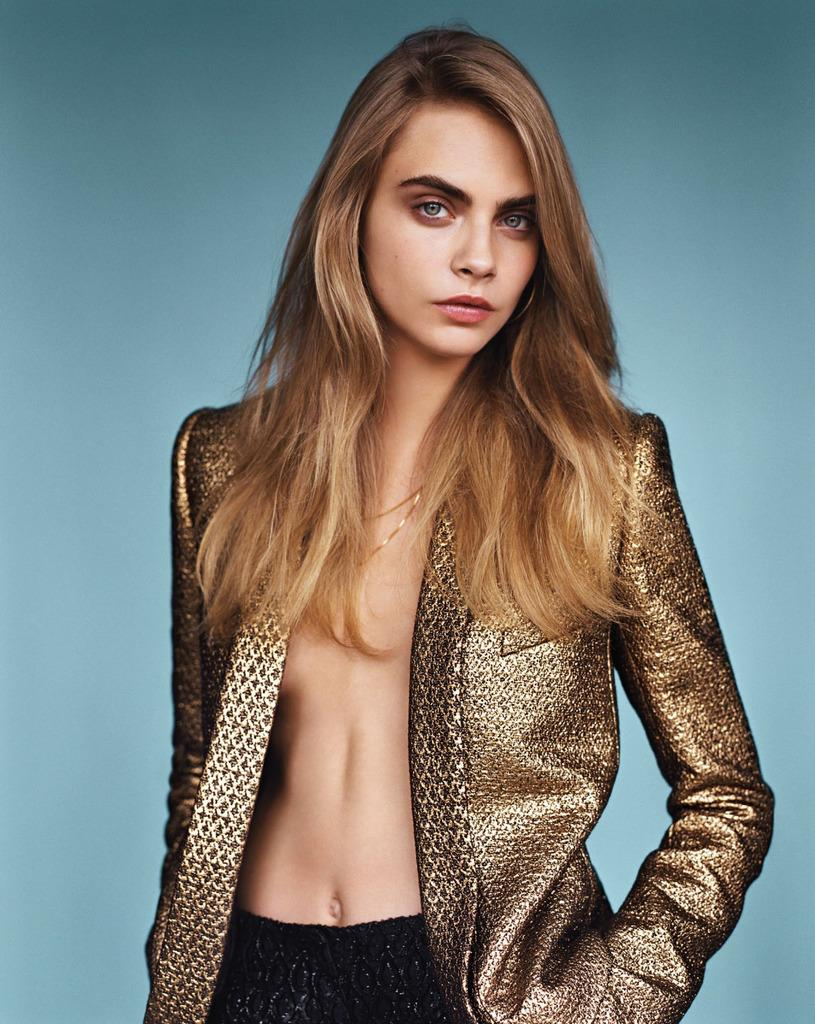What is the main subject of the image? There is a beautiful woman in the image. What is the woman wearing in the image? The woman is wearing a jacket. What is the woman doing in the image? The woman is giving a pose. What shape is the peace symbol in the image? There is no peace symbol present in the image. What type of doll is sitting next to the woman in the image? There is no doll present in the image. 